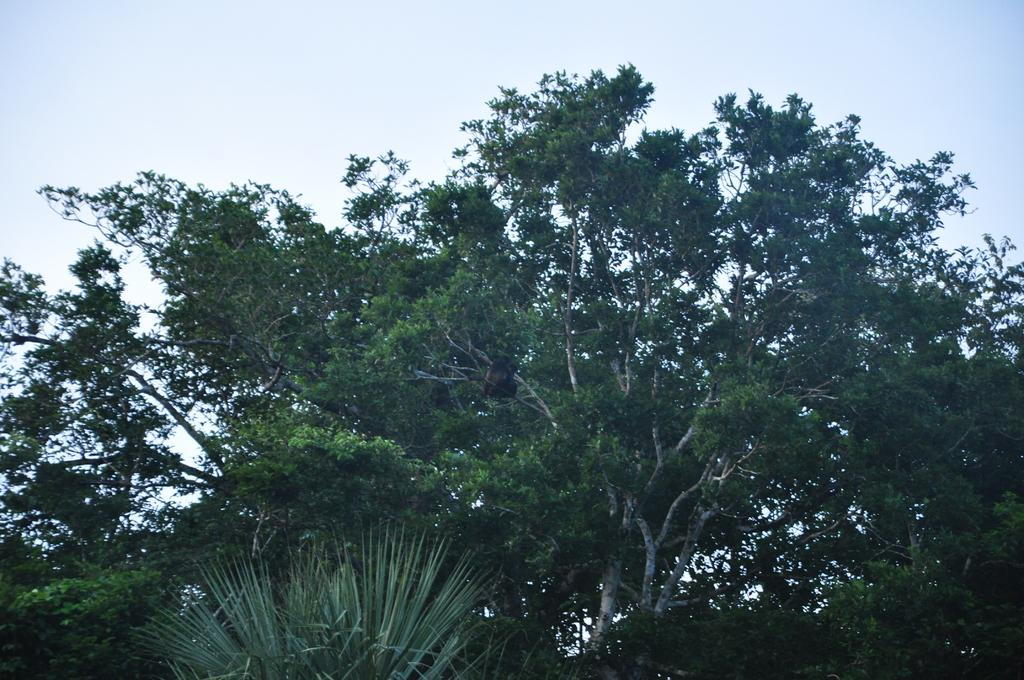What type of vegetation can be seen in the image? There are trees in the image. What part of the natural environment is visible in the image? The sky is visible in the background of the image. Are there any fairies flying around the trees in the image? There is no indication of fairies in the image; it only features trees and the sky. 